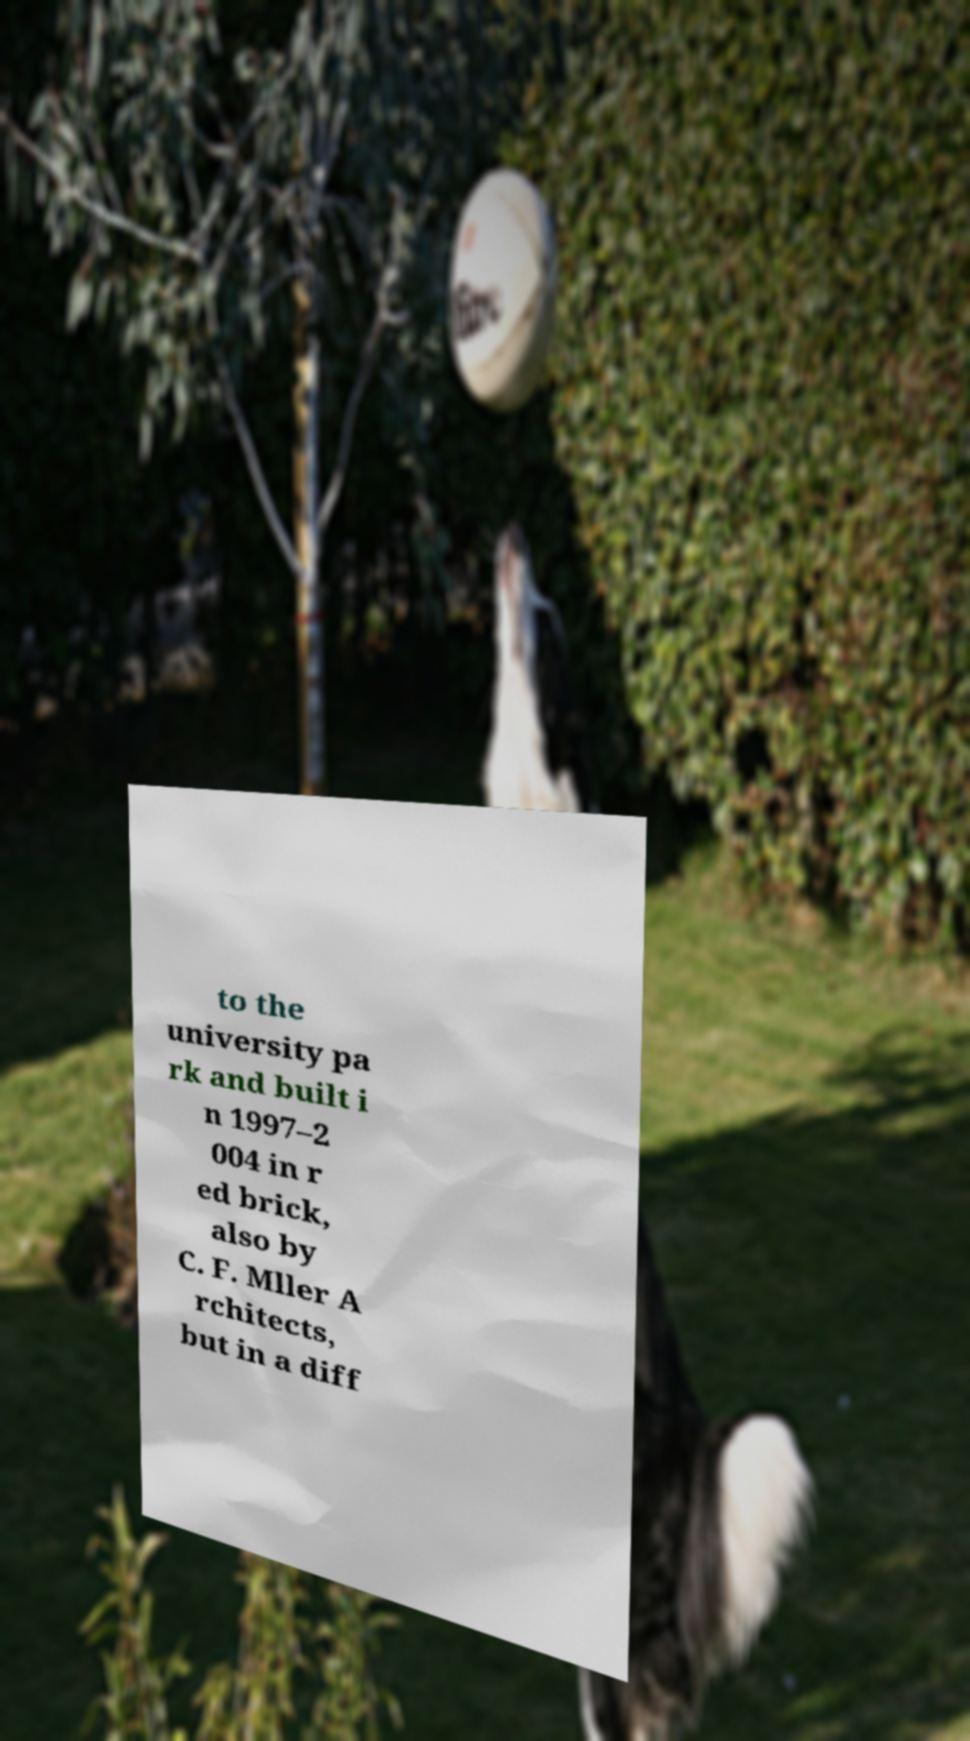Can you accurately transcribe the text from the provided image for me? to the university pa rk and built i n 1997–2 004 in r ed brick, also by C. F. Mller A rchitects, but in a diff 